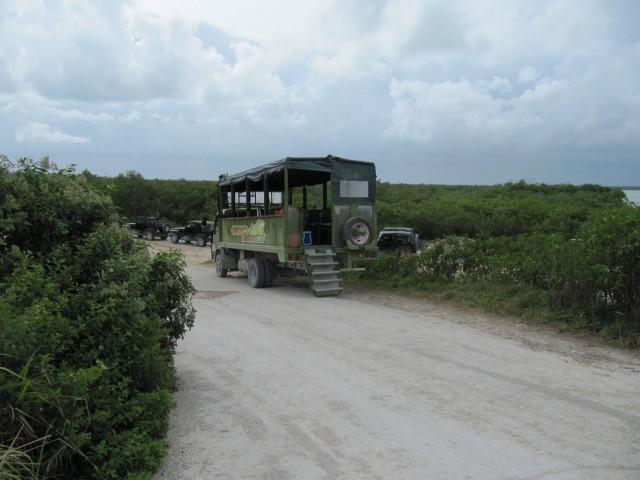Are the hedges well trimmed?
Concise answer only. No. What point of view is this picture taken?
Concise answer only. From ground. Is that a train?
Short answer required. No. Where are the stairs?
Answer briefly. On bus. What plant is covering the ground?
Keep it brief. Bushes. Is that a dirt road?
Be succinct. Yes. Can that vehicle run on a highway?
Write a very short answer. No. What color are the trees?
Write a very short answer. Green. What is the man riding on?
Be succinct. Truck. Is this a park?
Quick response, please. No. What color is the truck painted?
Short answer required. Green. What is the truck hauling?
Write a very short answer. People. Can you see a giraffe in the picture?
Be succinct. No. 